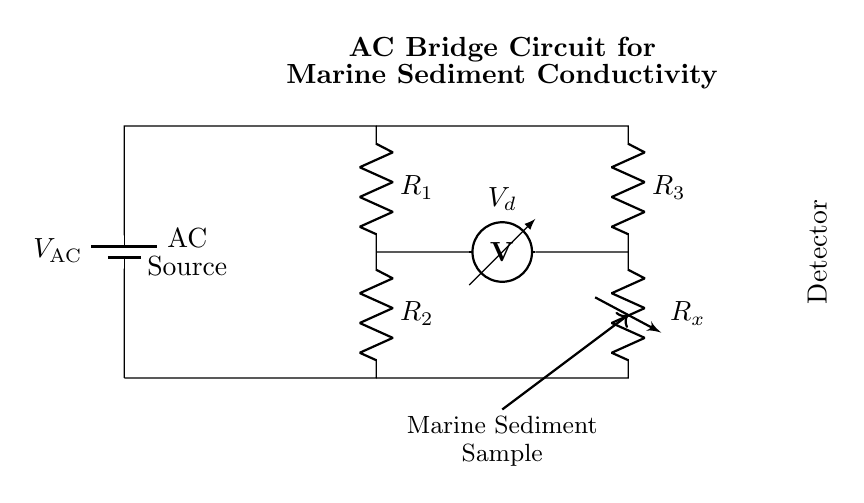What is the AC source labeled as? The AC source is labeled as "V_AC," indicating it is an alternating current voltage supply connected to the circuit.
Answer: V_AC What type of resistor is R_x? R_x is a variable resistor, which can adjust its resistance and is used for measuring the conductivity of the marine sediment sample connected in the circuit.
Answer: Variable resistor How many resistors are there in the circuit? There are four resistors in the circuit: R_1, R_2, R_3, and R_x. Each plays a role in balancing the AC bridge for conductivity measurement.
Answer: Four What does the voltmeter measure? The voltmeter measures the voltage drop across the resistors R_2 and R_3, which provides insights into the balance of the AC bridge and the conductivity of the marine sediment.
Answer: Voltage drop What is the purpose of the AC bridge circuit? The purpose of the AC bridge circuit is to analyze the electrical conductivity of marine sediments by comparing the resistance in the circuit to that of a known reference.
Answer: Analyze conductivity How is the marine sediment sample represented in the circuit? The marine sediment sample is represented in the circuit as part of the variable resistor R_x, indicating that its conductivity is being measured and compared in the AC bridge setup.
Answer: Variable resistor 